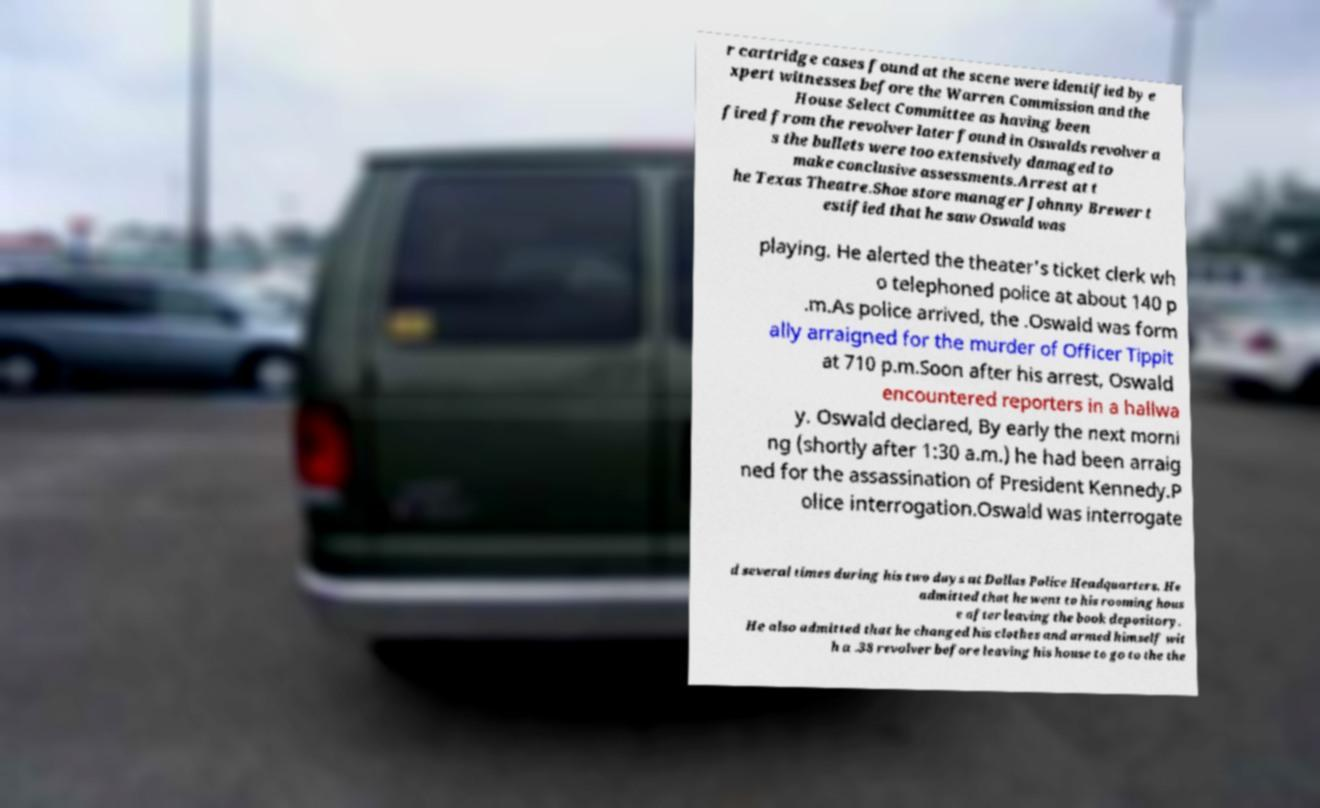Please read and relay the text visible in this image. What does it say? r cartridge cases found at the scene were identified by e xpert witnesses before the Warren Commission and the House Select Committee as having been fired from the revolver later found in Oswalds revolver a s the bullets were too extensively damaged to make conclusive assessments.Arrest at t he Texas Theatre.Shoe store manager Johnny Brewer t estified that he saw Oswald was playing. He alerted the theater's ticket clerk wh o telephoned police at about 140 p .m.As police arrived, the .Oswald was form ally arraigned for the murder of Officer Tippit at 710 p.m.Soon after his arrest, Oswald encountered reporters in a hallwa y. Oswald declared, By early the next morni ng (shortly after 1:30 a.m.) he had been arraig ned for the assassination of President Kennedy.P olice interrogation.Oswald was interrogate d several times during his two days at Dallas Police Headquarters. He admitted that he went to his rooming hous e after leaving the book depository. He also admitted that he changed his clothes and armed himself wit h a .38 revolver before leaving his house to go to the the 